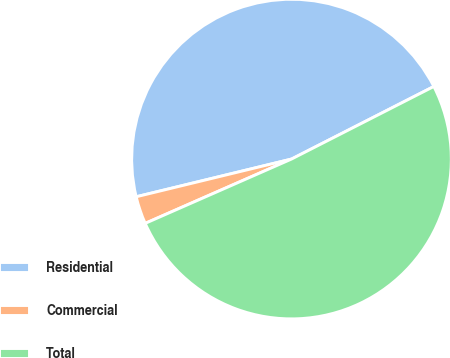Convert chart. <chart><loc_0><loc_0><loc_500><loc_500><pie_chart><fcel>Residential<fcel>Commercial<fcel>Total<nl><fcel>46.29%<fcel>2.8%<fcel>50.92%<nl></chart> 